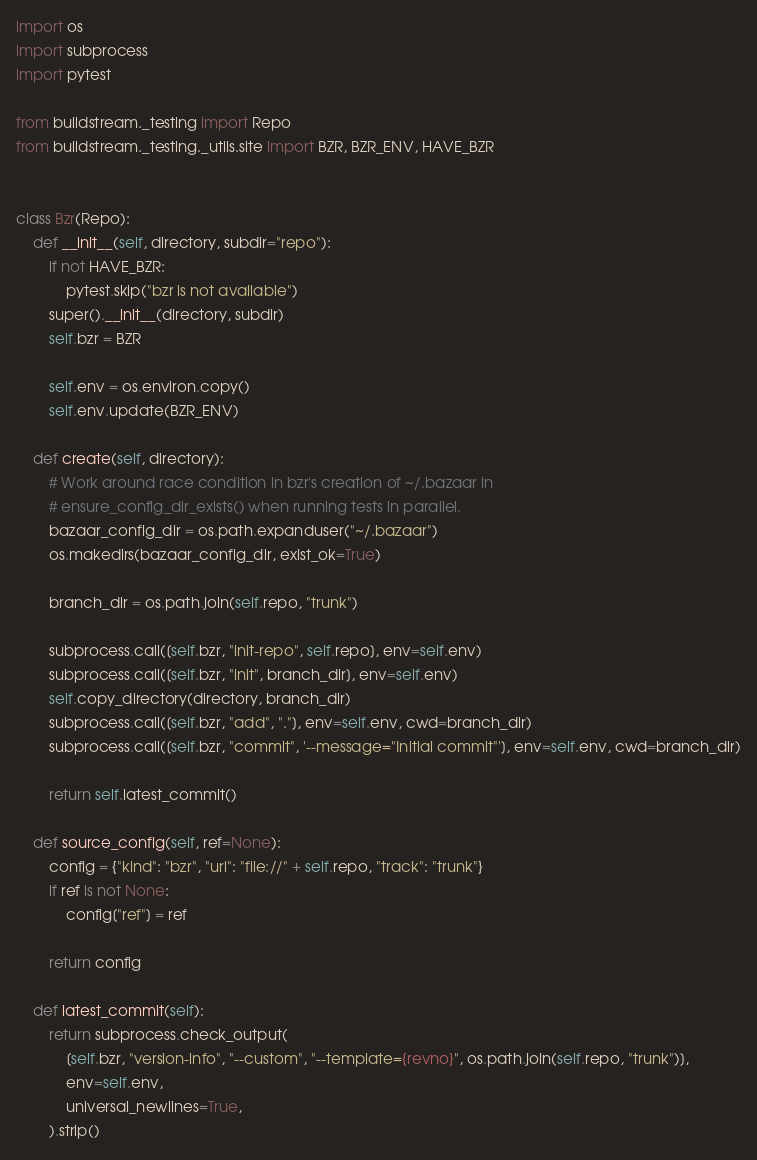Convert code to text. <code><loc_0><loc_0><loc_500><loc_500><_Python_>import os
import subprocess
import pytest

from buildstream._testing import Repo
from buildstream._testing._utils.site import BZR, BZR_ENV, HAVE_BZR


class Bzr(Repo):
    def __init__(self, directory, subdir="repo"):
        if not HAVE_BZR:
            pytest.skip("bzr is not available")
        super().__init__(directory, subdir)
        self.bzr = BZR

        self.env = os.environ.copy()
        self.env.update(BZR_ENV)

    def create(self, directory):
        # Work around race condition in bzr's creation of ~/.bazaar in
        # ensure_config_dir_exists() when running tests in parallel.
        bazaar_config_dir = os.path.expanduser("~/.bazaar")
        os.makedirs(bazaar_config_dir, exist_ok=True)

        branch_dir = os.path.join(self.repo, "trunk")

        subprocess.call([self.bzr, "init-repo", self.repo], env=self.env)
        subprocess.call([self.bzr, "init", branch_dir], env=self.env)
        self.copy_directory(directory, branch_dir)
        subprocess.call([self.bzr, "add", "."], env=self.env, cwd=branch_dir)
        subprocess.call([self.bzr, "commit", '--message="Initial commit"'], env=self.env, cwd=branch_dir)

        return self.latest_commit()

    def source_config(self, ref=None):
        config = {"kind": "bzr", "url": "file://" + self.repo, "track": "trunk"}
        if ref is not None:
            config["ref"] = ref

        return config

    def latest_commit(self):
        return subprocess.check_output(
            [self.bzr, "version-info", "--custom", "--template={revno}", os.path.join(self.repo, "trunk")],
            env=self.env,
            universal_newlines=True,
        ).strip()
</code> 